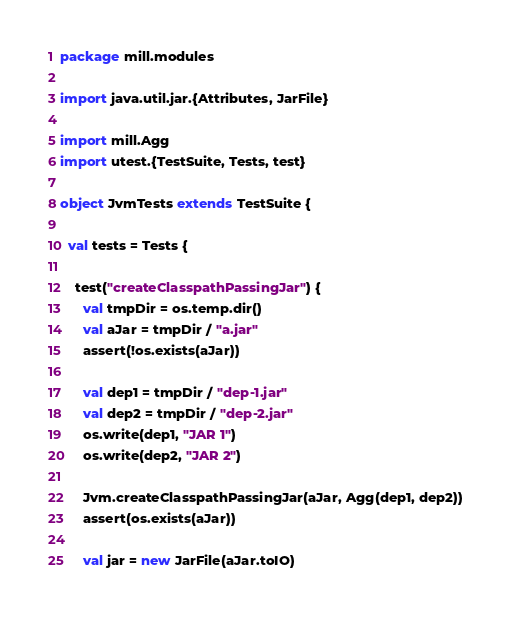<code> <loc_0><loc_0><loc_500><loc_500><_Scala_>package mill.modules

import java.util.jar.{Attributes, JarFile}

import mill.Agg
import utest.{TestSuite, Tests, test}

object JvmTests extends TestSuite {

  val tests = Tests {

    test("createClasspathPassingJar") {
      val tmpDir = os.temp.dir()
      val aJar = tmpDir / "a.jar"
      assert(!os.exists(aJar))

      val dep1 = tmpDir / "dep-1.jar"
      val dep2 = tmpDir / "dep-2.jar"
      os.write(dep1, "JAR 1")
      os.write(dep2, "JAR 2")

      Jvm.createClasspathPassingJar(aJar, Agg(dep1, dep2))
      assert(os.exists(aJar))

      val jar = new JarFile(aJar.toIO)</code> 